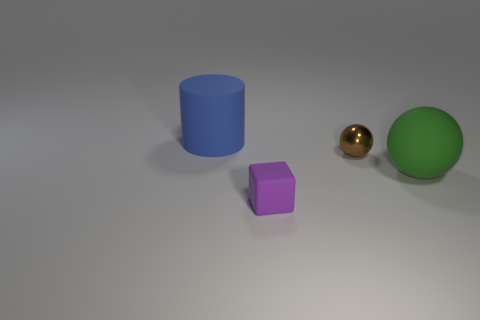Subtract 0 blue blocks. How many objects are left? 4 Subtract all cylinders. How many objects are left? 3 Subtract 2 spheres. How many spheres are left? 0 Subtract all gray cubes. Subtract all red cylinders. How many cubes are left? 1 Subtract all yellow cylinders. How many green balls are left? 1 Subtract all big blue rubber objects. Subtract all metal spheres. How many objects are left? 2 Add 2 tiny purple cubes. How many tiny purple cubes are left? 3 Add 4 blue matte cylinders. How many blue matte cylinders exist? 5 Add 2 small brown shiny things. How many objects exist? 6 